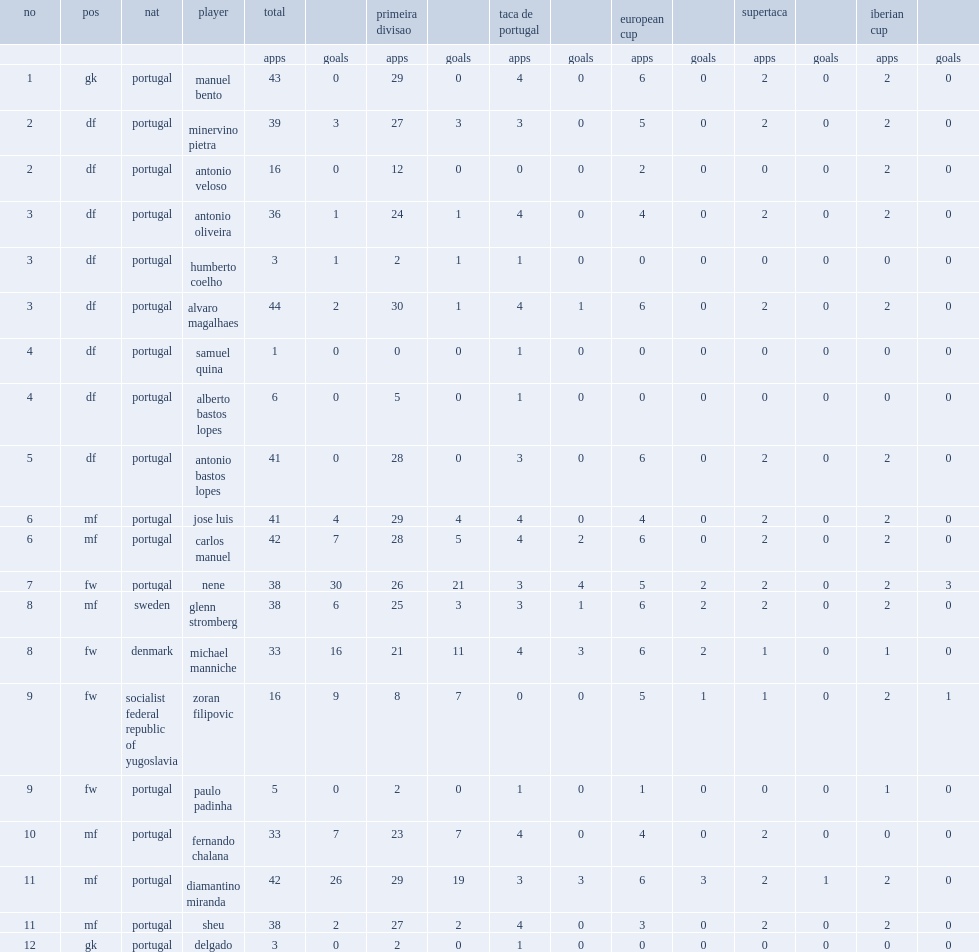What the matches did benfica compete in? Primeira divisao taca de portugal european cup supertaca. 